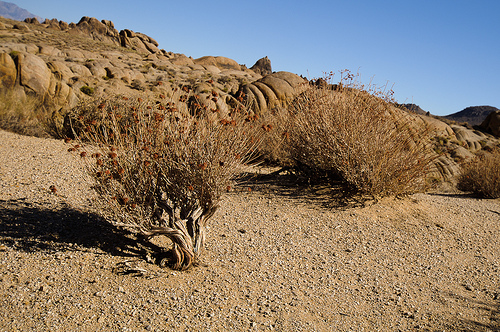<image>
Is the stone above the tree? No. The stone is not positioned above the tree. The vertical arrangement shows a different relationship. 